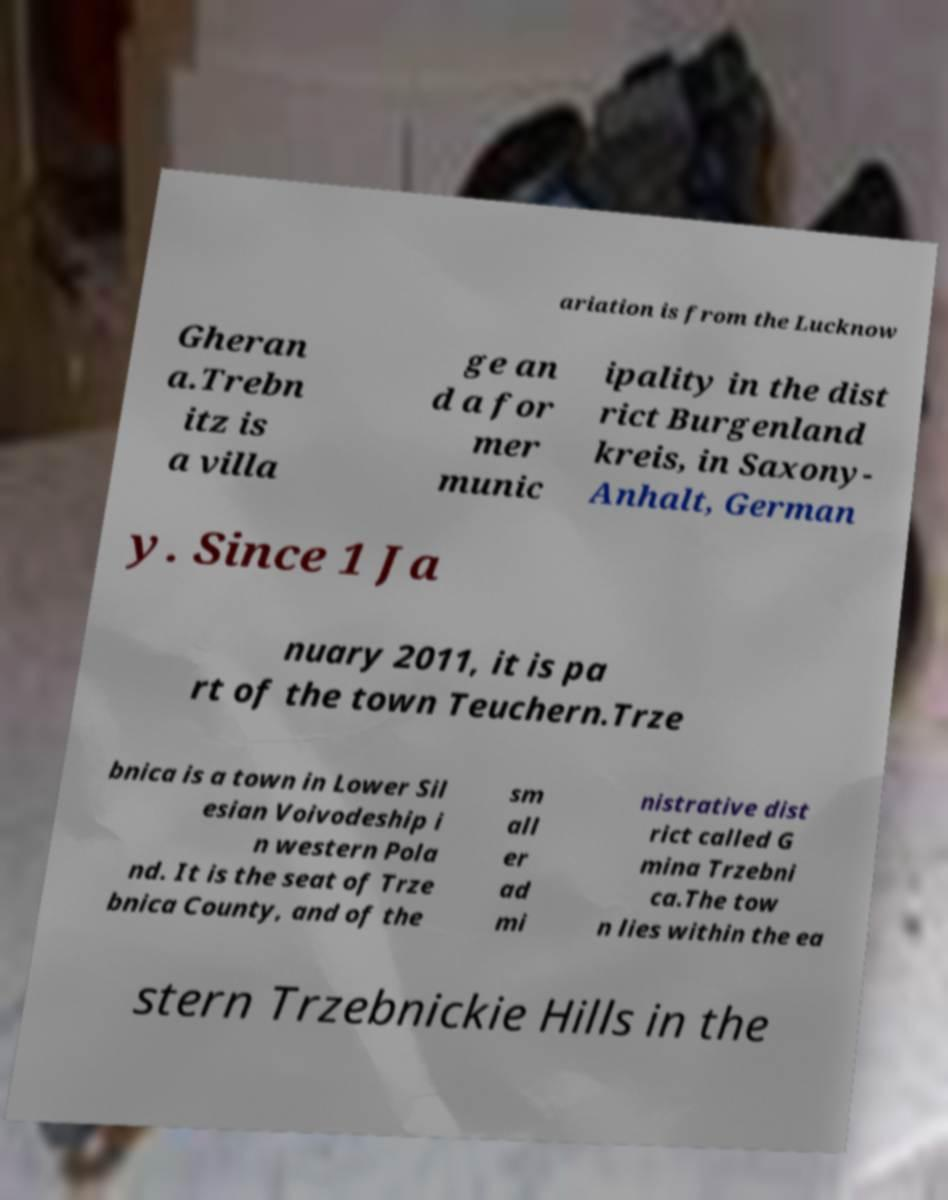Can you read and provide the text displayed in the image?This photo seems to have some interesting text. Can you extract and type it out for me? ariation is from the Lucknow Gheran a.Trebn itz is a villa ge an d a for mer munic ipality in the dist rict Burgenland kreis, in Saxony- Anhalt, German y. Since 1 Ja nuary 2011, it is pa rt of the town Teuchern.Trze bnica is a town in Lower Sil esian Voivodeship i n western Pola nd. It is the seat of Trze bnica County, and of the sm all er ad mi nistrative dist rict called G mina Trzebni ca.The tow n lies within the ea stern Trzebnickie Hills in the 